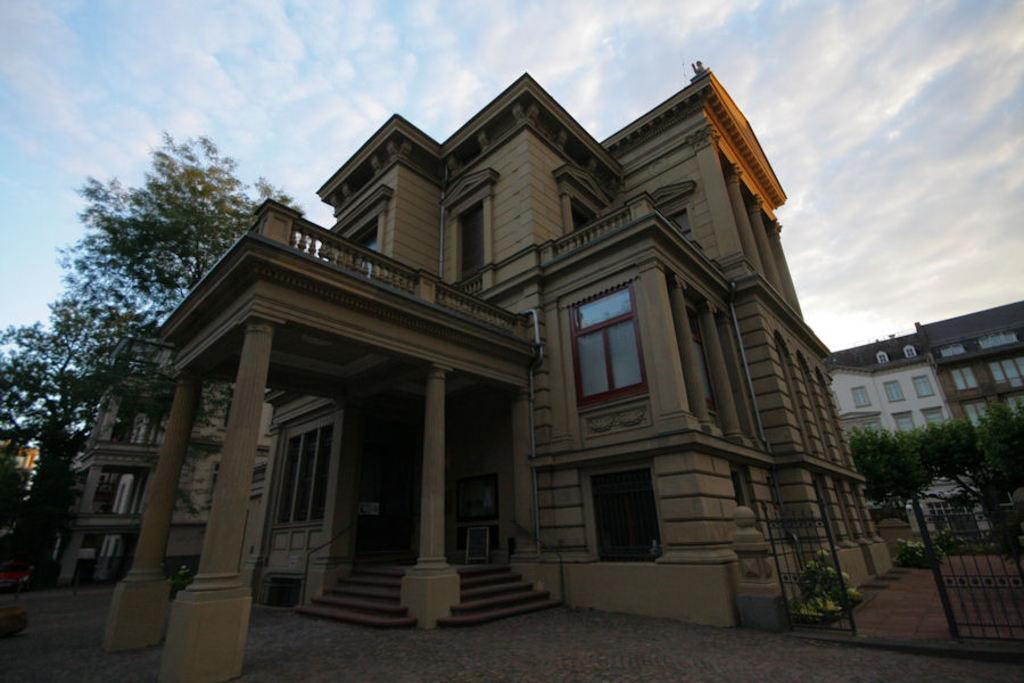What colors are used for the buildings in the image? The buildings in the image are in brown and cream color. What can be seen at the entrance of the buildings? There is a gate visible in the image. What type of vegetation is in the background of the image? There are trees in the background of the image. What is the color of the trees? The trees are green in color. What is visible in the sky in the image? The sky is blue and white in color. What letters are being shaken by the trees in the image? There are no letters being shaken by the trees in the image. The trees are simply green in color, and there is no indication of any letters or shaking motion. 